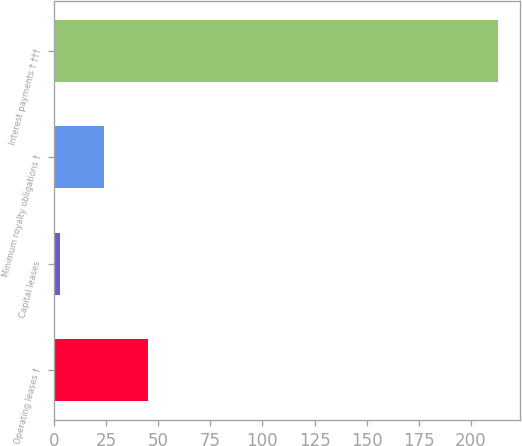Convert chart. <chart><loc_0><loc_0><loc_500><loc_500><bar_chart><fcel>Operating leases †<fcel>Capital leases<fcel>Minimum royalty obligations †<fcel>Interest payments † †††<nl><fcel>45<fcel>3<fcel>24<fcel>213<nl></chart> 